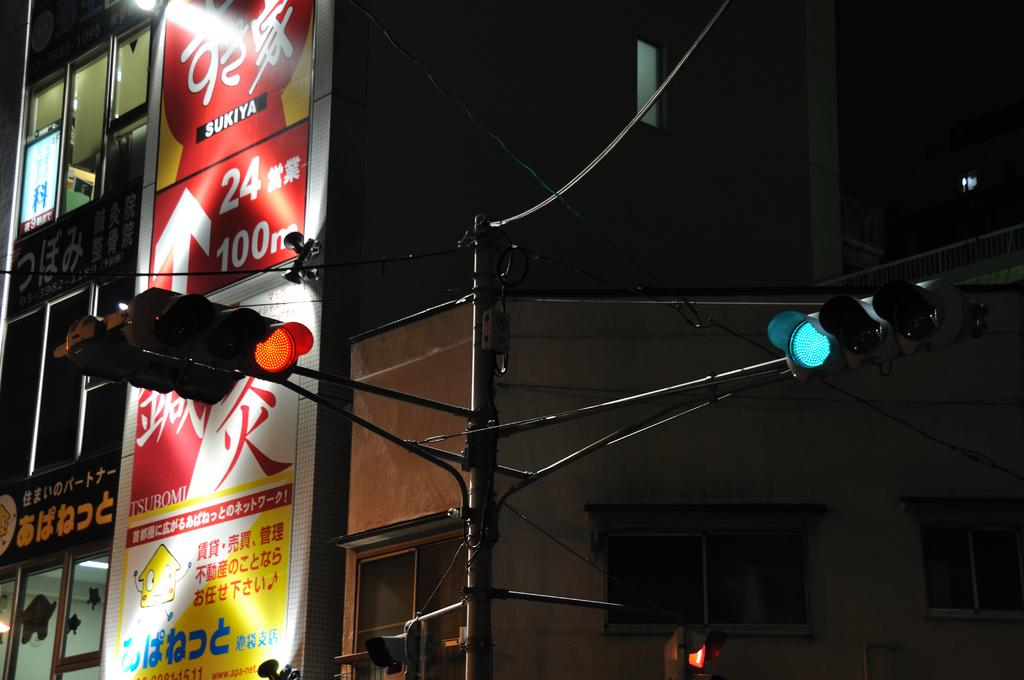<image>
Describe the image concisely. an intersection with a red sukiya billboard in the background. 